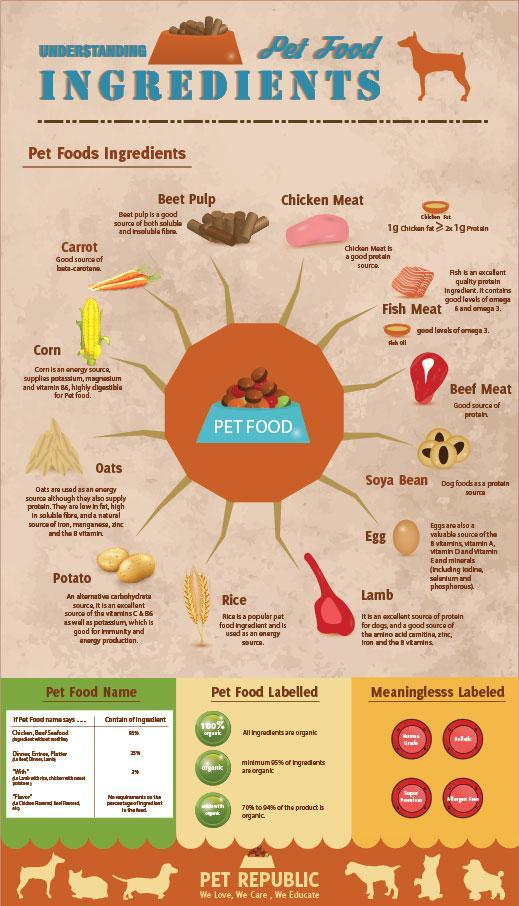Which legume is considered to be a good source of protein for pet?
Answer the question with a short phrase. Soya Bean Which pet food is the valuable source of B vitamins, Vitamin A,D,E and minerals? Egg Which is a popular pet food ingredient used as an energy source? Rice Which oil provides a good levels of omega 3 in pet foods? fish oil Which pet food is considered as a good source of both soluble & insoluble fibre? Beet Pulp Which pet food is good for both immunity & energy production? Potato 